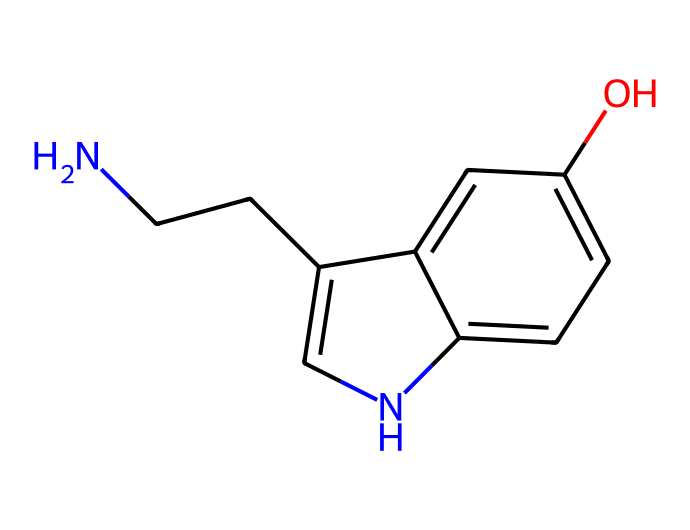What is the molecular formula of serotonin? By analyzing the structure represented by the SMILES notation, we count the elements: Carbon (C), Hydrogen (H), Nitrogen (N), and Oxygen (O). The counts are: 10 Carbon atoms, 12 Hydrogen atoms, 1 Nitrogen atom, and 1 Oxygen atom. Therefore, the molecular formula is C10H12N2O.
Answer: C10H12N2O How many rings are present in the structure? Looking at the SMILES representation, we can identify two ring systems in the chemical structure (the cyclic parts are denoted by the entries ‘1’ and ‘2’ in the SMILES). Both rings consist of interconnected atoms contributing to the bicyclic nature of serotonin.
Answer: 2 What functional group is present in serotonin? The presence of an -OH group in the structure, which indicates a hydroxyl group, is a defining characteristic of phenolic compounds. This hydroxyl group contributes to serotonin's solubility in water and its activity in biological systems.
Answer: hydroxyl group What type of neurotransmitter is serotonin? Given the structural elements like the amine group (indicated by the nitrogen atom) and its biological role in mood regulation, serotonin is classified as a monoamine neurotransmitter. This classification arises from its synthesis from single amine precursor amino acids.
Answer: monoamine Is serotonin more likely to be hydrophobic or hydrophilic? The presence of oxygen in the hydroxyl group (-OH) and the polar nitrogen atom increase the water-solubility of serotonin, indicating it has hydrophilic characteristics. The nature and structure of the molecule highlight its affinities for aqueous environments within the body.
Answer: hydrophilic Does serotonin have any chiral centers? By examining the structure, we note that there is a carbon atom attached to four different substituents (the carbon after the nitrogen atom), which qualifies it as a chiral center. Hence, serotonin can exist in two enantiomeric forms.
Answer: yes 